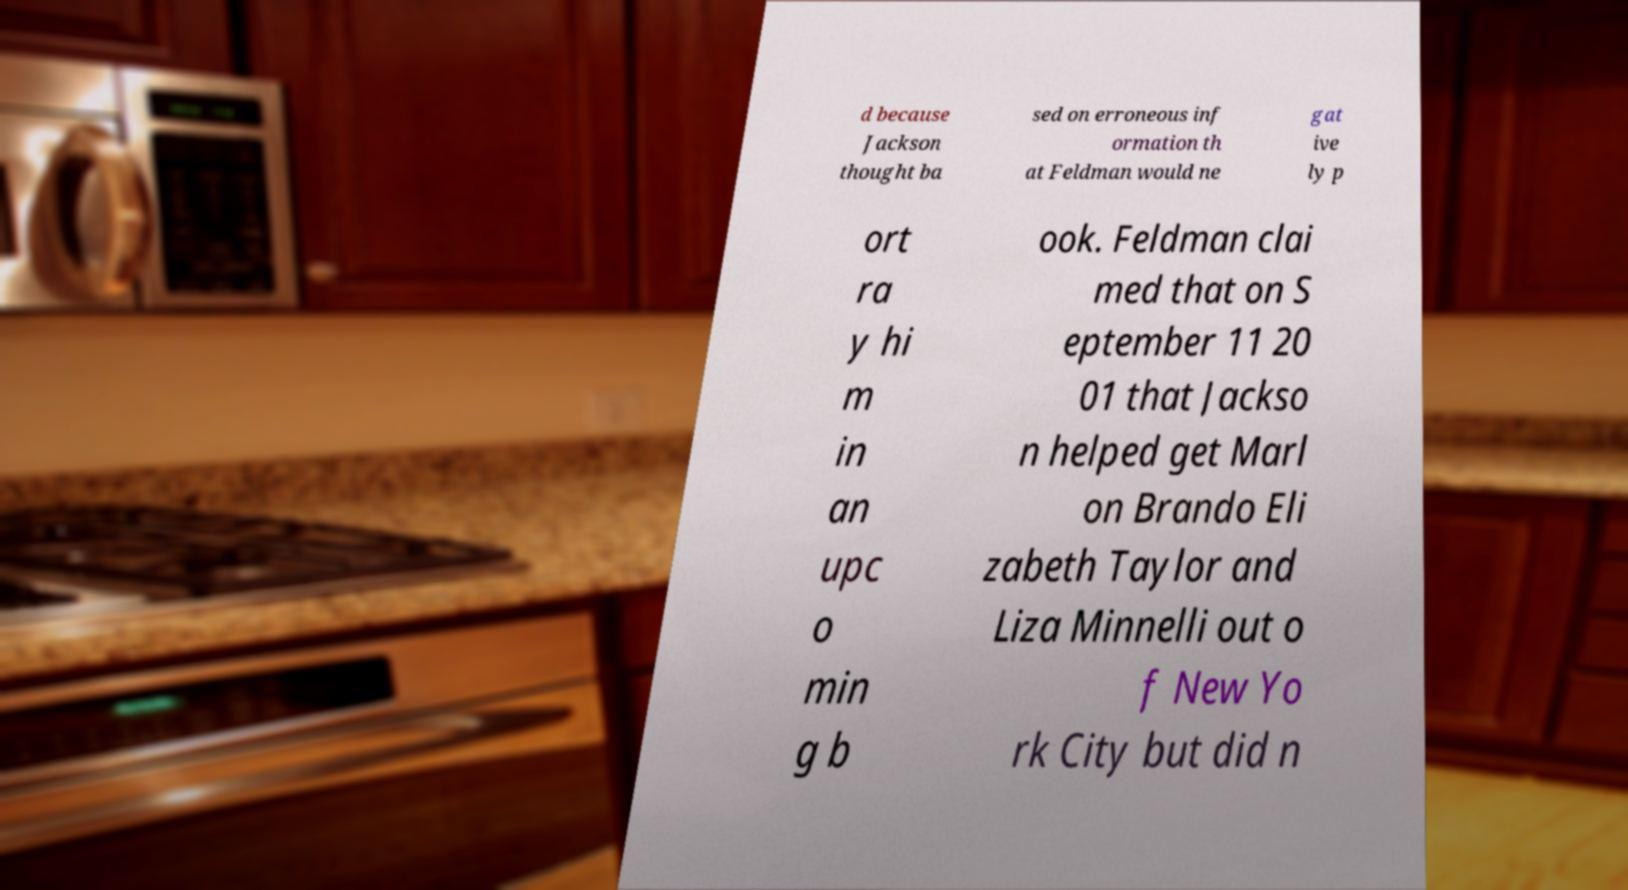Could you extract and type out the text from this image? d because Jackson thought ba sed on erroneous inf ormation th at Feldman would ne gat ive ly p ort ra y hi m in an upc o min g b ook. Feldman clai med that on S eptember 11 20 01 that Jackso n helped get Marl on Brando Eli zabeth Taylor and Liza Minnelli out o f New Yo rk City but did n 